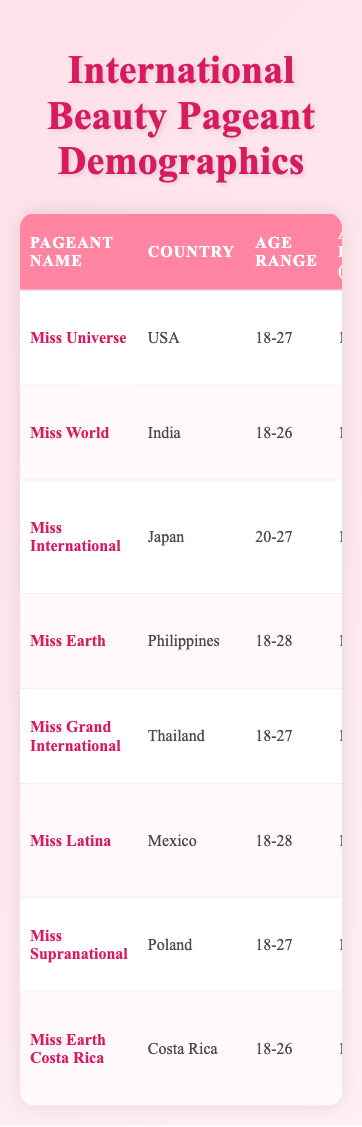What is the average height of participants in Miss Universe? The height of participants in Miss Universe is listed as 175 cm in the table, so the average height is simply 175 cm.
Answer: 175 cm Which pageant has participants with an average weight of 57 kg? The table shows that Miss Supranational has participants with an average weight of 57 kg.
Answer: Miss Supranational Are there participants from Costa Rica in any international pageants listed? Yes, the table includes Miss Earth Costa Rica, which is specifically a pageant from Costa Rica.
Answer: Yes What is the age range of participants in Miss Earth? The table provides the age range for Miss Earth as 18-28, which is taken directly from the relevant row.
Answer: 18-28 Which pageant participants have the most common hair color of black and average height of less than 170 cm? By checking the rows, Miss International and Miss Earth both have black hair color; however, Miss International has an average height of 165 cm, which is less than 170 cm, making it the answer.
Answer: Miss International How many countries have participants with an average height of at least 170 cm? The pageants are Miss Universe (175 cm), Miss World (170 cm), Miss Grand International (172 cm), and Miss Supranational (174 cm). Thus, there are four pageants corresponding to four countries that have an average height of at least 170 cm.
Answer: 4 Do participants in Miss Latina have a common eye color of blue? The table states that participants in Miss Latina have a common eye color of brown, not blue, which confirms the answer to be no.
Answer: No What is the difference between the average heights of participants in Miss Earth and Miss International? The average height in Miss Earth is 168 cm and in Miss International it is 165 cm. The difference is calculated as 168 cm - 165 cm = 3 cm.
Answer: 3 cm Which pageant has a primary focus on environmental advocacy? According to the data, Miss Earth focuses on environmental advocacy and sustainability, which is explicitly stated in its background description.
Answer: Miss Earth 